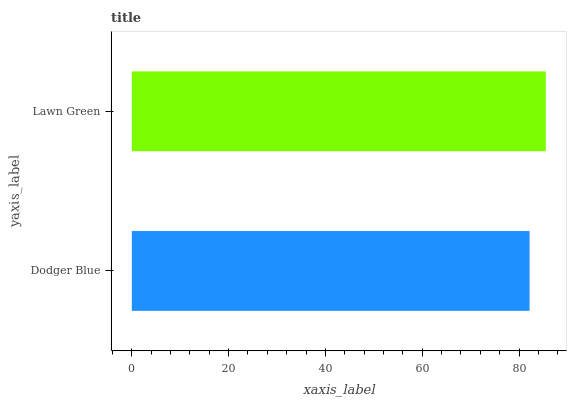Is Dodger Blue the minimum?
Answer yes or no. Yes. Is Lawn Green the maximum?
Answer yes or no. Yes. Is Lawn Green the minimum?
Answer yes or no. No. Is Lawn Green greater than Dodger Blue?
Answer yes or no. Yes. Is Dodger Blue less than Lawn Green?
Answer yes or no. Yes. Is Dodger Blue greater than Lawn Green?
Answer yes or no. No. Is Lawn Green less than Dodger Blue?
Answer yes or no. No. Is Lawn Green the high median?
Answer yes or no. Yes. Is Dodger Blue the low median?
Answer yes or no. Yes. Is Dodger Blue the high median?
Answer yes or no. No. Is Lawn Green the low median?
Answer yes or no. No. 